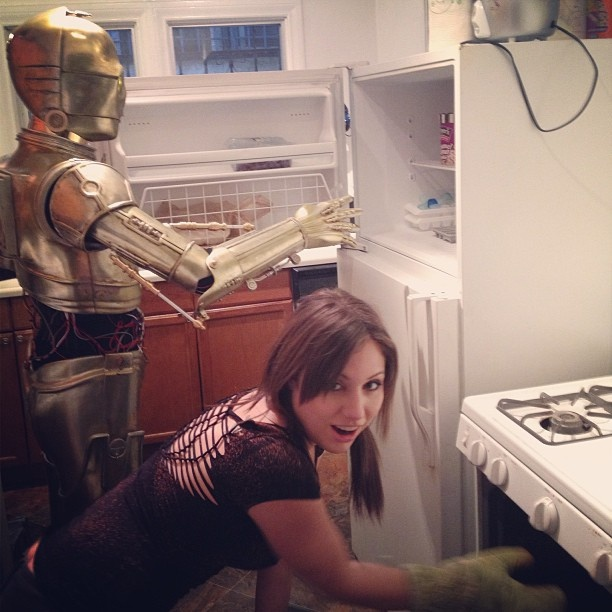Describe the objects in this image and their specific colors. I can see refrigerator in tan, darkgray, and lightgray tones, people in tan, black, maroon, and brown tones, and oven in tan, ivory, black, and darkgray tones in this image. 